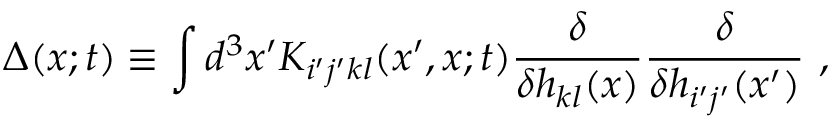Convert formula to latex. <formula><loc_0><loc_0><loc_500><loc_500>\Delta ( x ; t ) \equiv \int d ^ { 3 } x ^ { \prime } K _ { i ^ { \prime } j ^ { \prime } k l } ( x ^ { \prime } , x ; t ) \frac { \delta } { \delta h _ { k l } ( x ) } \frac { \delta } { \delta h _ { i ^ { \prime } j ^ { \prime } } ( x ^ { \prime } ) } \ ,</formula> 